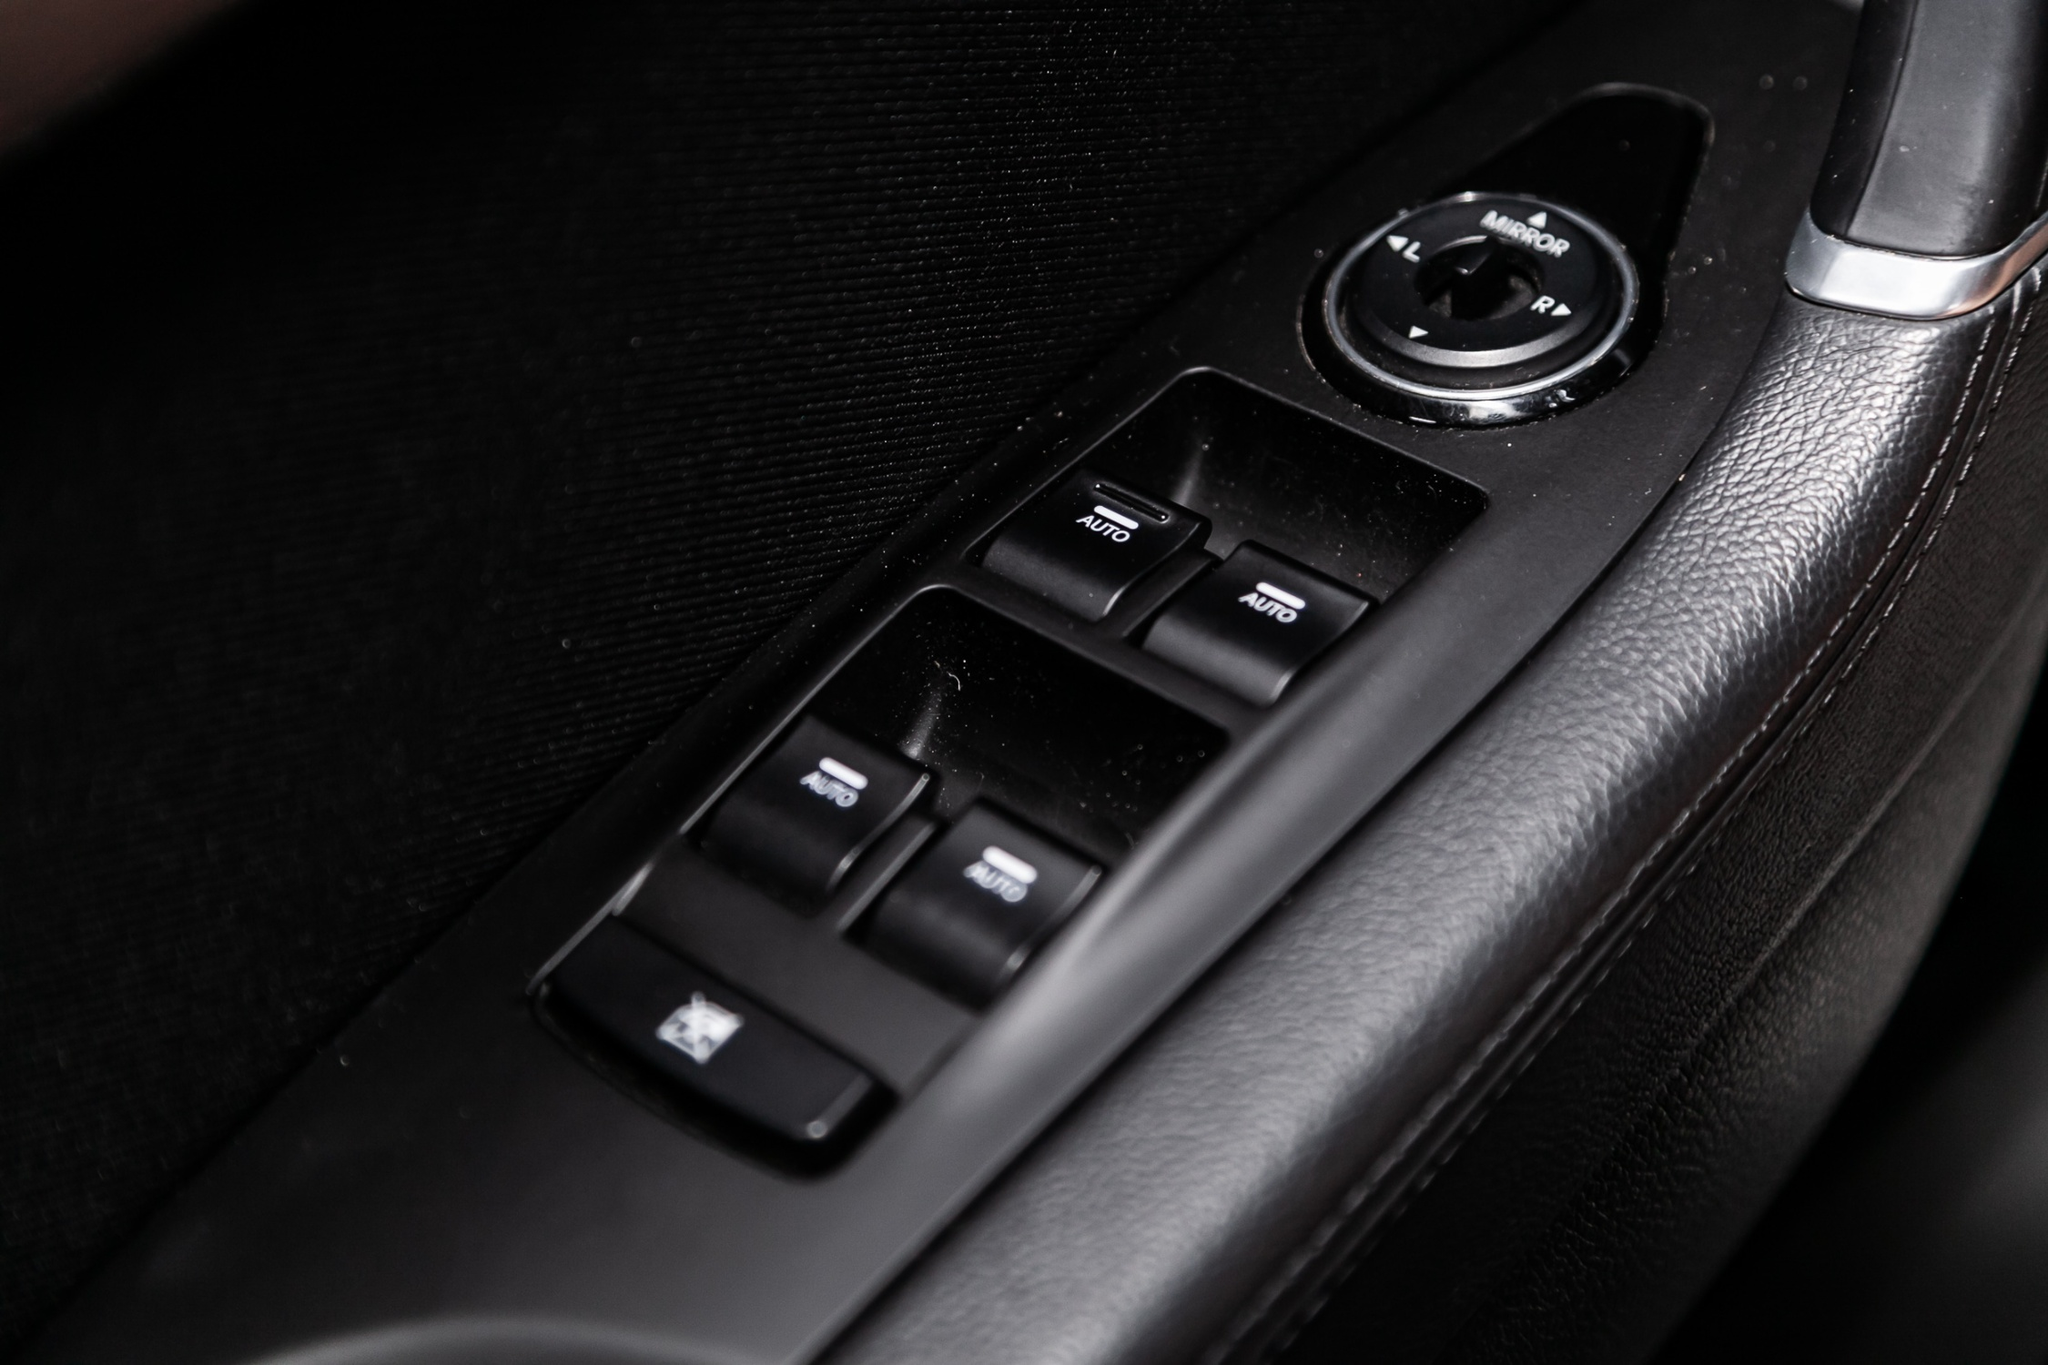Imagine if the buttons on this panel could talk. What would they say? Welcome to your ride! I'm Auto, delighted to assist you with seamless window operations. Just press me, and I'll glide your windows up or down—effortlessly!

Hey there, I'm Power. Need anything powered? I'm your go-to button for activating those essential features. Ready and at your service!

Hi! I'm the Lock—your security guardian. Just a push, and I'll keep those doors secure. Feel safe and sound with me around.

Mirror here! Adjust me to see your surroundings better—I’ll make sure you're always in the clear. 